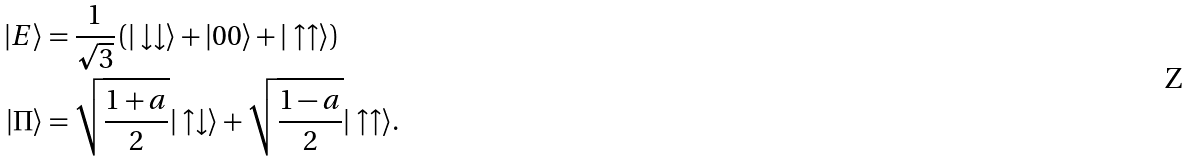<formula> <loc_0><loc_0><loc_500><loc_500>| E \rangle & = \frac { 1 } { \sqrt { 3 } } \left ( | \downarrow \downarrow \rangle + | 0 0 \rangle + | \uparrow \uparrow \rangle \right ) \\ | \Pi \rangle & = \sqrt { \frac { 1 + a } { 2 } } | \uparrow \downarrow \rangle + \sqrt { \frac { 1 - a } { 2 } } | \uparrow \uparrow \rangle .</formula> 